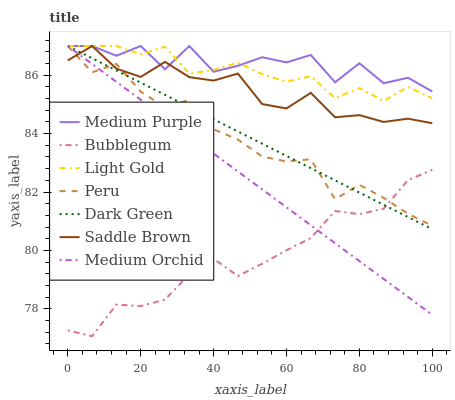Does Bubblegum have the minimum area under the curve?
Answer yes or no. Yes. Does Medium Purple have the maximum area under the curve?
Answer yes or no. Yes. Does Medium Purple have the minimum area under the curve?
Answer yes or no. No. Does Bubblegum have the maximum area under the curve?
Answer yes or no. No. Is Medium Orchid the smoothest?
Answer yes or no. Yes. Is Medium Purple the roughest?
Answer yes or no. Yes. Is Bubblegum the smoothest?
Answer yes or no. No. Is Bubblegum the roughest?
Answer yes or no. No. Does Bubblegum have the lowest value?
Answer yes or no. Yes. Does Medium Purple have the lowest value?
Answer yes or no. No. Does Dark Green have the highest value?
Answer yes or no. Yes. Does Bubblegum have the highest value?
Answer yes or no. No. Is Bubblegum less than Medium Purple?
Answer yes or no. Yes. Is Light Gold greater than Bubblegum?
Answer yes or no. Yes. Does Peru intersect Light Gold?
Answer yes or no. Yes. Is Peru less than Light Gold?
Answer yes or no. No. Is Peru greater than Light Gold?
Answer yes or no. No. Does Bubblegum intersect Medium Purple?
Answer yes or no. No. 